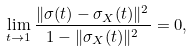<formula> <loc_0><loc_0><loc_500><loc_500>\lim _ { t \to 1 } \frac { \| \sigma ( t ) - \sigma _ { X } ( t ) \| ^ { 2 } } { 1 - \| \sigma _ { X } ( t ) \| ^ { 2 } } = 0 ,</formula> 